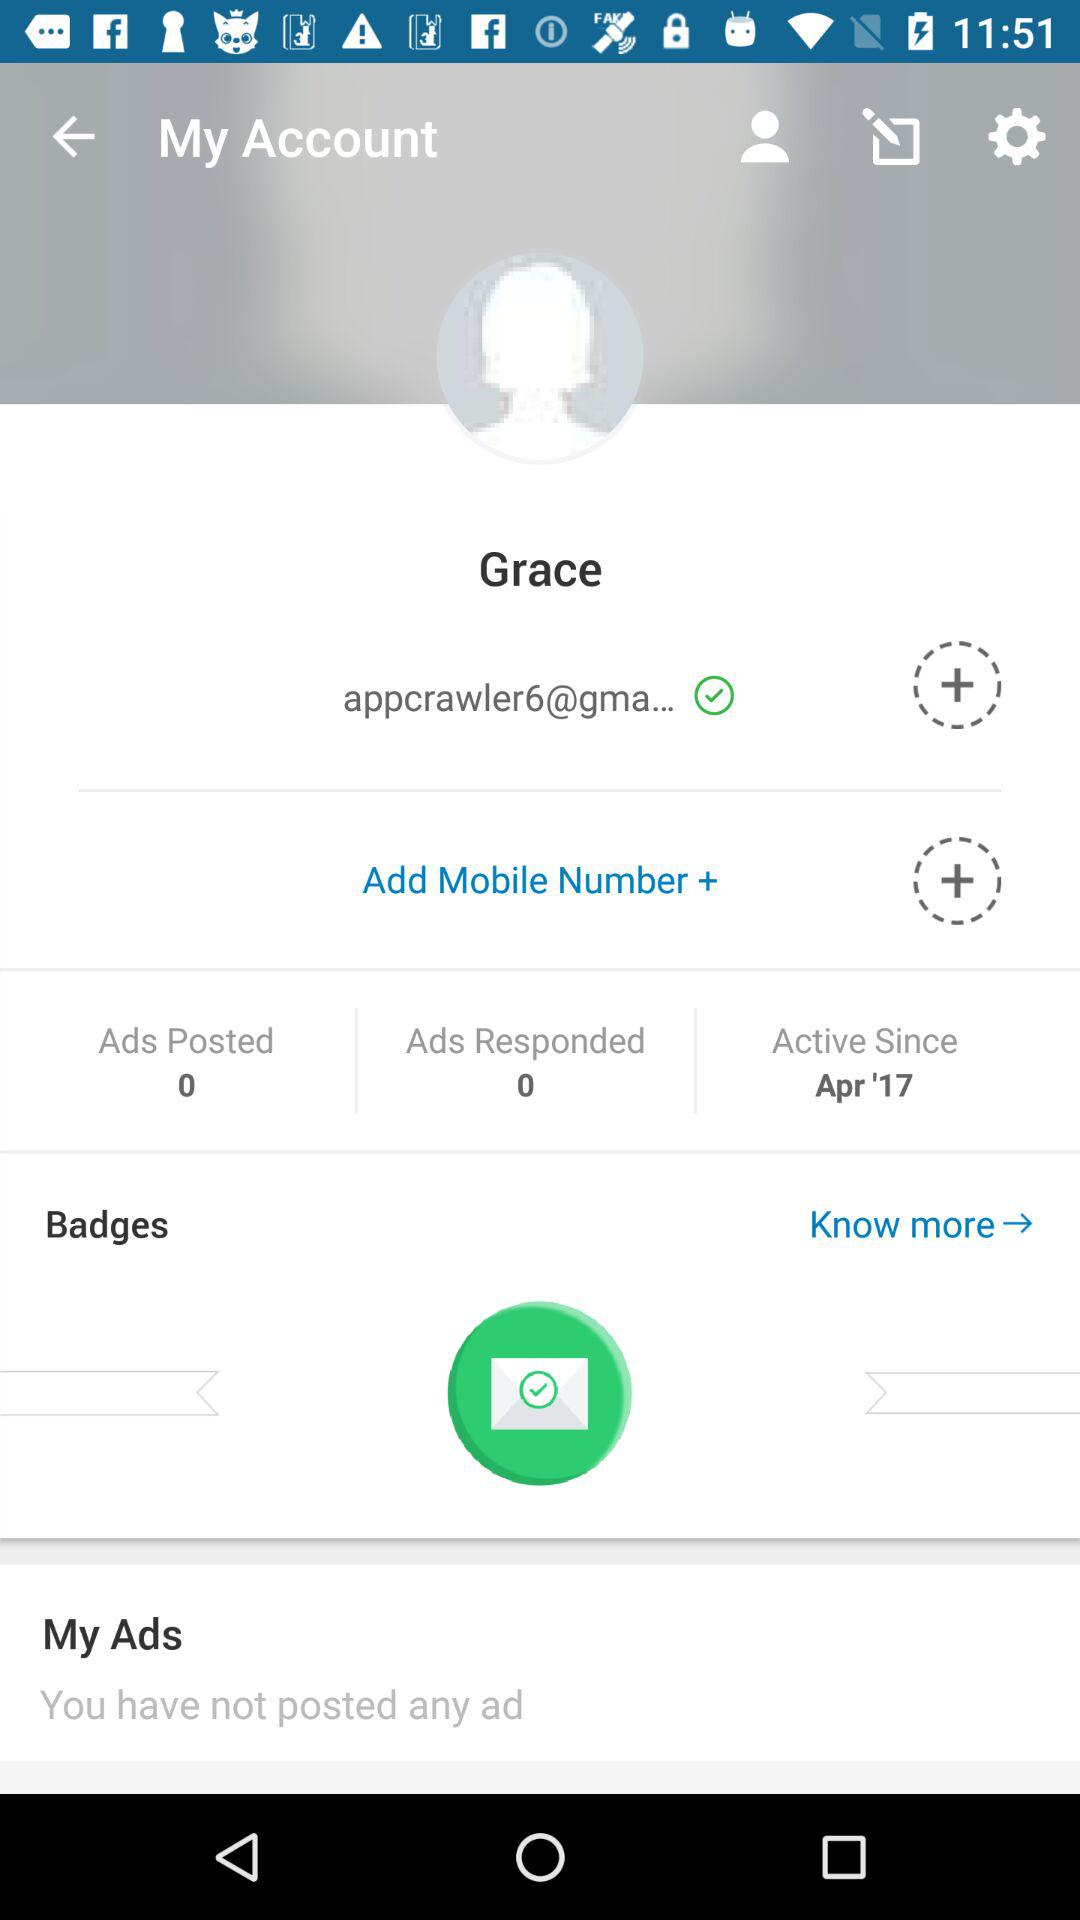What's the Gmail address? The Gmail address is "appcrawler6@gma...". 